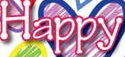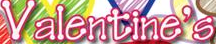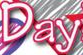What words are shown in these images in order, separated by a semicolon? Happy; Valentine's; Day 